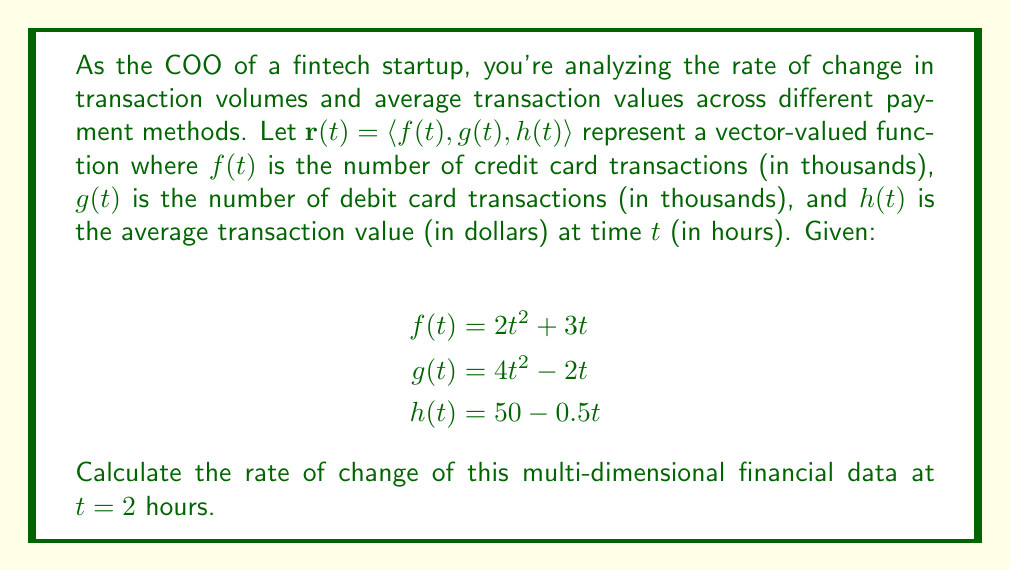Solve this math problem. To solve this problem, we need to follow these steps:

1) First, we need to find the derivative of the vector-valued function $\mathbf{r}(t)$. This is done by differentiating each component:

   $$\mathbf{r}'(t) = \langle f'(t), g'(t), h'(t) \rangle$$

2) Let's differentiate each component:

   $f'(t) = \frac{d}{dt}(2t^2 + 3t) = 4t + 3$
   
   $g'(t) = \frac{d}{dt}(4t^2 - 2t) = 8t - 2$
   
   $h'(t) = \frac{d}{dt}(50 - 0.5t) = -0.5$

3) Therefore, 

   $$\mathbf{r}'(t) = \langle 4t + 3, 8t - 2, -0.5 \rangle$$

4) Now, we need to evaluate this at $t = 2$:

   $$\mathbf{r}'(2) = \langle 4(2) + 3, 8(2) - 2, -0.5 \rangle$$
   
   $$= \langle 11, 14, -0.5 \rangle$$

5) This vector represents the rate of change at $t = 2$ hours:
   - Credit card transactions are increasing at a rate of 11,000 per hour
   - Debit card transactions are increasing at a rate of 14,000 per hour
   - The average transaction value is decreasing at a rate of $0.50 per hour

The magnitude of this rate of change can be calculated using the vector magnitude formula:

$$\|\mathbf{r}'(2)\| = \sqrt{11^2 + 14^2 + (-0.5)^2} \approx 17.80$$

This represents the overall rate of change considering all dimensions.
Answer: The rate of change of the multi-dimensional financial data at $t = 2$ hours is $\mathbf{r}'(2) = \langle 11, 14, -0.5 \rangle$, with a magnitude of approximately 17.80 units per hour. 